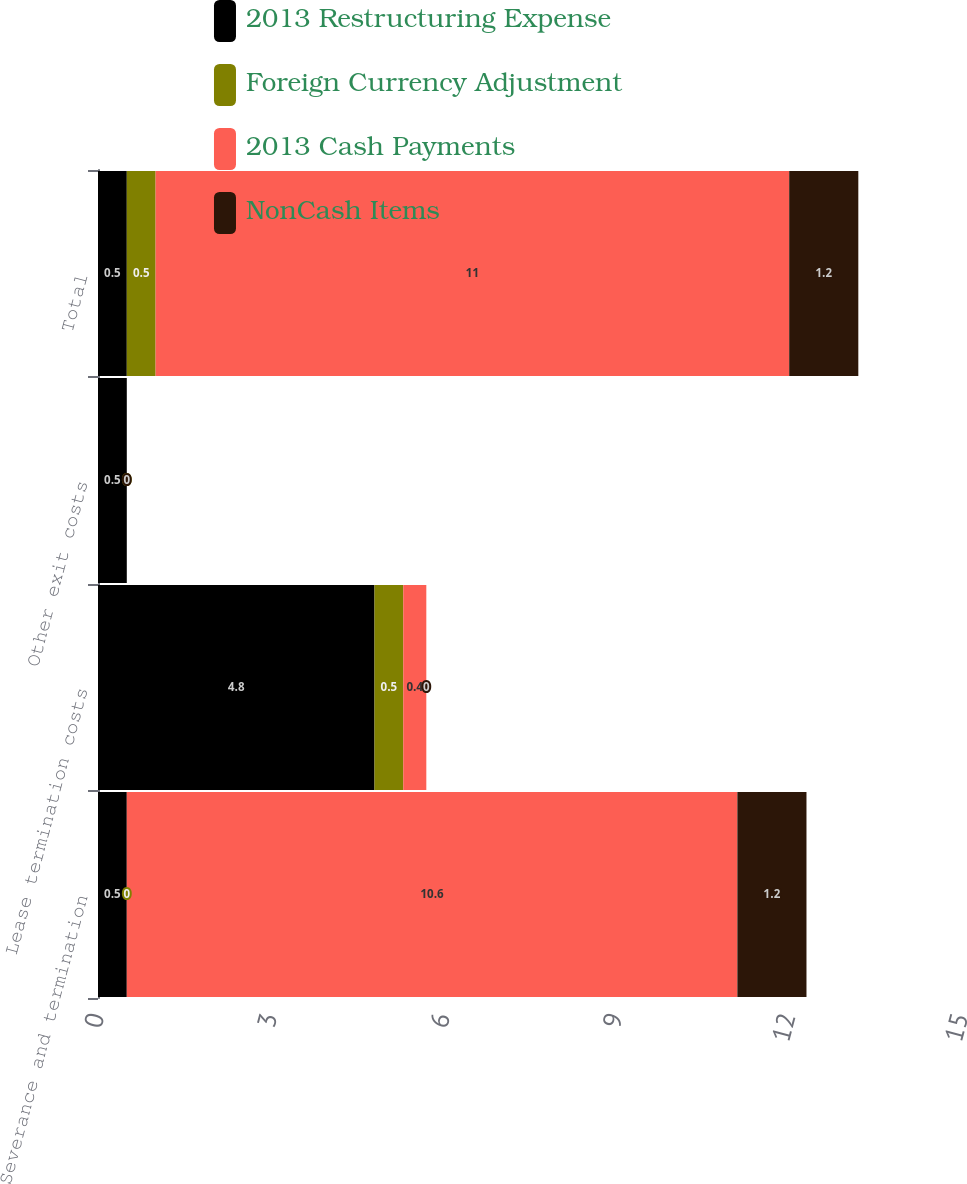<chart> <loc_0><loc_0><loc_500><loc_500><stacked_bar_chart><ecel><fcel>Severance and termination<fcel>Lease termination costs<fcel>Other exit costs<fcel>Total<nl><fcel>2013 Restructuring Expense<fcel>0.5<fcel>4.8<fcel>0.5<fcel>0.5<nl><fcel>Foreign Currency Adjustment<fcel>0<fcel>0.5<fcel>0<fcel>0.5<nl><fcel>2013 Cash Payments<fcel>10.6<fcel>0.4<fcel>0<fcel>11<nl><fcel>NonCash Items<fcel>1.2<fcel>0<fcel>0<fcel>1.2<nl></chart> 